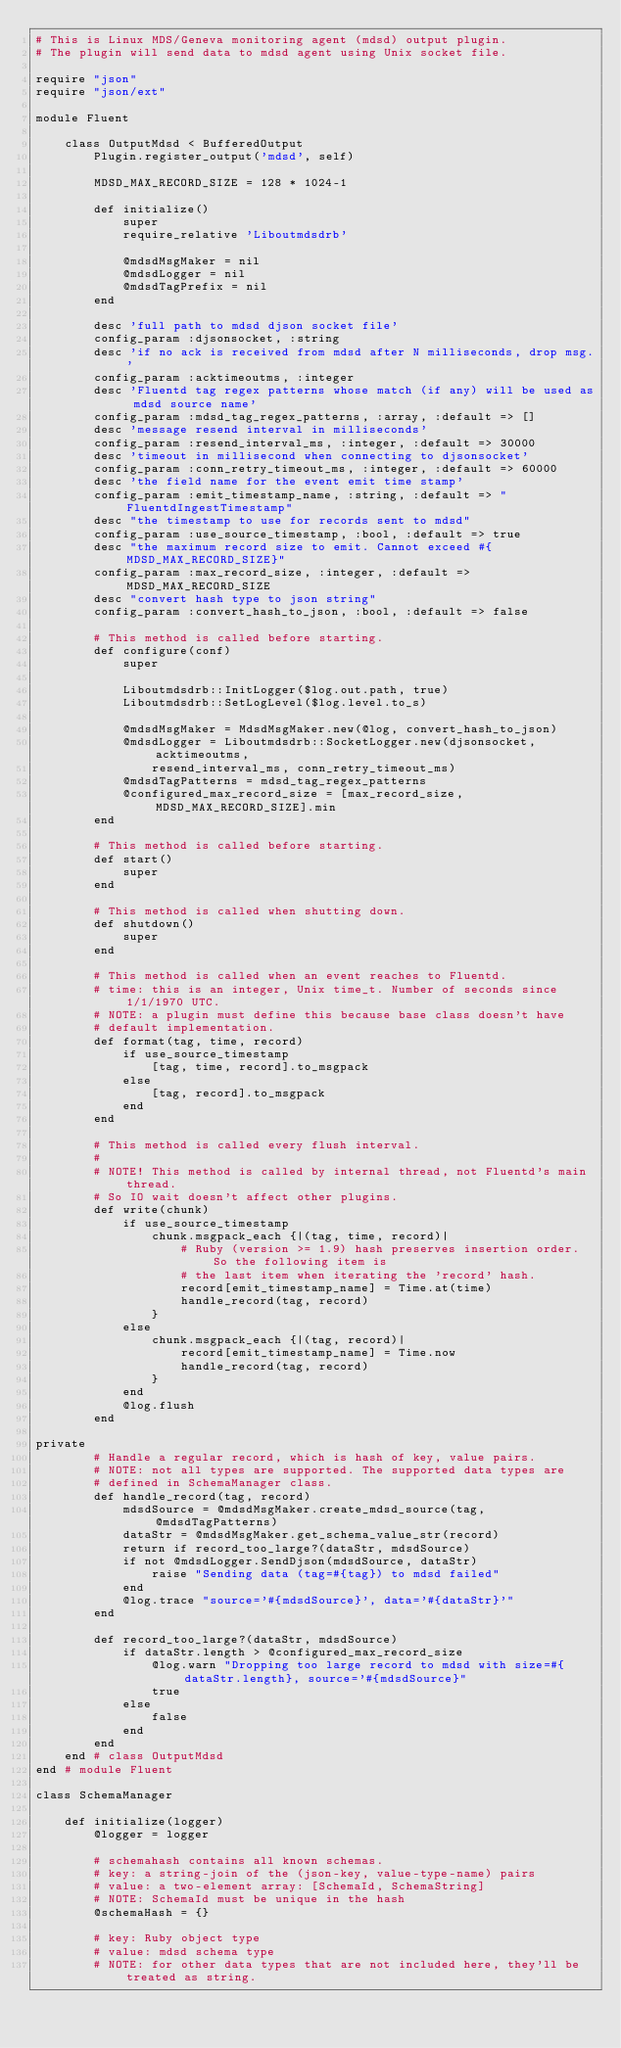Convert code to text. <code><loc_0><loc_0><loc_500><loc_500><_Ruby_># This is Linux MDS/Geneva monitoring agent (mdsd) output plugin.
# The plugin will send data to mdsd agent using Unix socket file.

require "json"
require "json/ext"

module Fluent

    class OutputMdsd < BufferedOutput
        Plugin.register_output('mdsd', self)

        MDSD_MAX_RECORD_SIZE = 128 * 1024-1

        def initialize()
            super
            require_relative 'Liboutmdsdrb'

            @mdsdMsgMaker = nil
            @mdsdLogger = nil
            @mdsdTagPrefix = nil
        end

        desc 'full path to mdsd djson socket file'
        config_param :djsonsocket, :string
        desc 'if no ack is received from mdsd after N milliseconds, drop msg.'
        config_param :acktimeoutms, :integer
        desc 'Fluentd tag regex patterns whose match (if any) will be used as mdsd source name'
        config_param :mdsd_tag_regex_patterns, :array, :default => []
        desc 'message resend interval in milliseconds'
        config_param :resend_interval_ms, :integer, :default => 30000
        desc 'timeout in millisecond when connecting to djsonsocket'
        config_param :conn_retry_timeout_ms, :integer, :default => 60000
        desc 'the field name for the event emit time stamp'
        config_param :emit_timestamp_name, :string, :default => "FluentdIngestTimestamp"
        desc "the timestamp to use for records sent to mdsd"
        config_param :use_source_timestamp, :bool, :default => true
        desc "the maximum record size to emit. Cannot exceed #{MDSD_MAX_RECORD_SIZE}"
        config_param :max_record_size, :integer, :default => MDSD_MAX_RECORD_SIZE
        desc "convert hash type to json string"
        config_param :convert_hash_to_json, :bool, :default => false

        # This method is called before starting.
        def configure(conf)
            super

            Liboutmdsdrb::InitLogger($log.out.path, true)
            Liboutmdsdrb::SetLogLevel($log.level.to_s)

            @mdsdMsgMaker = MdsdMsgMaker.new(@log, convert_hash_to_json)
            @mdsdLogger = Liboutmdsdrb::SocketLogger.new(djsonsocket, acktimeoutms,
                resend_interval_ms, conn_retry_timeout_ms)
            @mdsdTagPatterns = mdsd_tag_regex_patterns
            @configured_max_record_size = [max_record_size, MDSD_MAX_RECORD_SIZE].min
        end

        # This method is called before starting.
        def start()
            super
        end

        # This method is called when shutting down.
        def shutdown()
            super
        end

        # This method is called when an event reaches to Fluentd.
        # time: this is an integer, Unix time_t. Number of seconds since 1/1/1970 UTC.
        # NOTE: a plugin must define this because base class doesn't have
        # default implementation.
        def format(tag, time, record)
            if use_source_timestamp
                [tag, time, record].to_msgpack
            else
                [tag, record].to_msgpack
            end
        end

        # This method is called every flush interval.
        #
        # NOTE! This method is called by internal thread, not Fluentd's main thread.
        # So IO wait doesn't affect other plugins.
        def write(chunk)
            if use_source_timestamp
                chunk.msgpack_each {|(tag, time, record)|
                    # Ruby (version >= 1.9) hash preserves insertion order. So the following item is
                    # the last item when iterating the 'record' hash.
                    record[emit_timestamp_name] = Time.at(time)
                    handle_record(tag, record)
                }
            else
                chunk.msgpack_each {|(tag, record)|
                    record[emit_timestamp_name] = Time.now
                    handle_record(tag, record)
                }
            end
            @log.flush
        end

private
        # Handle a regular record, which is hash of key, value pairs.
        # NOTE: not all types are supported. The supported data types are
        # defined in SchemaManager class.
        def handle_record(tag, record)
            mdsdSource = @mdsdMsgMaker.create_mdsd_source(tag, @mdsdTagPatterns)
            dataStr = @mdsdMsgMaker.get_schema_value_str(record)
            return if record_too_large?(dataStr, mdsdSource)
            if not @mdsdLogger.SendDjson(mdsdSource, dataStr)
                raise "Sending data (tag=#{tag}) to mdsd failed"
            end
            @log.trace "source='#{mdsdSource}', data='#{dataStr}'"
        end

        def record_too_large?(dataStr, mdsdSource)
            if dataStr.length > @configured_max_record_size
                @log.warn "Dropping too large record to mdsd with size=#{dataStr.length}, source='#{mdsdSource}"
                true
            else
                false
            end
        end
    end # class OutputMdsd
end # module Fluent

class SchemaManager

    def initialize(logger)
        @logger = logger

        # schemahash contains all known schemas.
        # key: a string-join of the (json-key, value-type-name) pairs
        # value: a two-element array: [SchemaId, SchemaString]
        # NOTE: SchemaId must be unique in the hash
        @schemaHash = {}

        # key: Ruby object type
        # value: mdsd schema type
        # NOTE: for other data types that are not included here, they'll be treated as string.</code> 